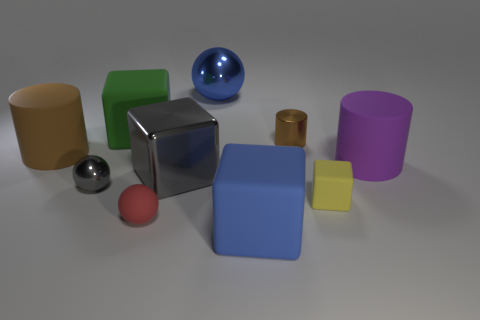Subtract all big spheres. How many spheres are left? 2 Subtract all purple cylinders. How many cylinders are left? 2 Subtract all cubes. How many objects are left? 6 Subtract 2 cubes. How many cubes are left? 2 Subtract all red blocks. Subtract all brown balls. How many blocks are left? 4 Subtract all brown spheres. How many red blocks are left? 0 Subtract all blue spheres. Subtract all small things. How many objects are left? 5 Add 7 brown cylinders. How many brown cylinders are left? 9 Add 4 small brown things. How many small brown things exist? 5 Subtract 0 gray cylinders. How many objects are left? 10 